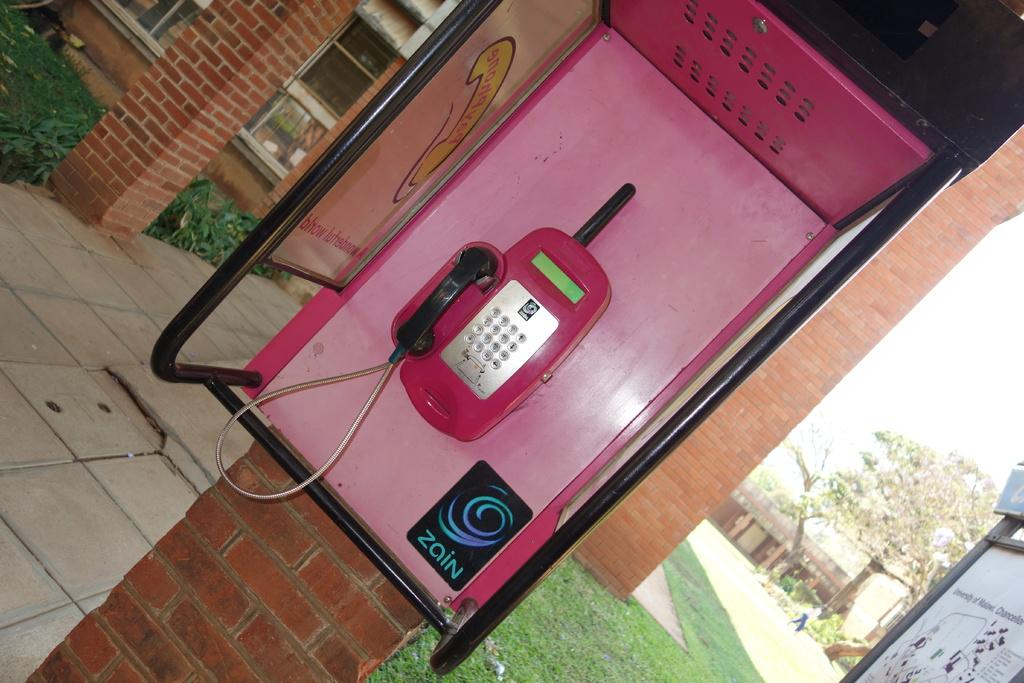<image>
Describe the image concisely. Zain is the word on the poster in this phone box. 